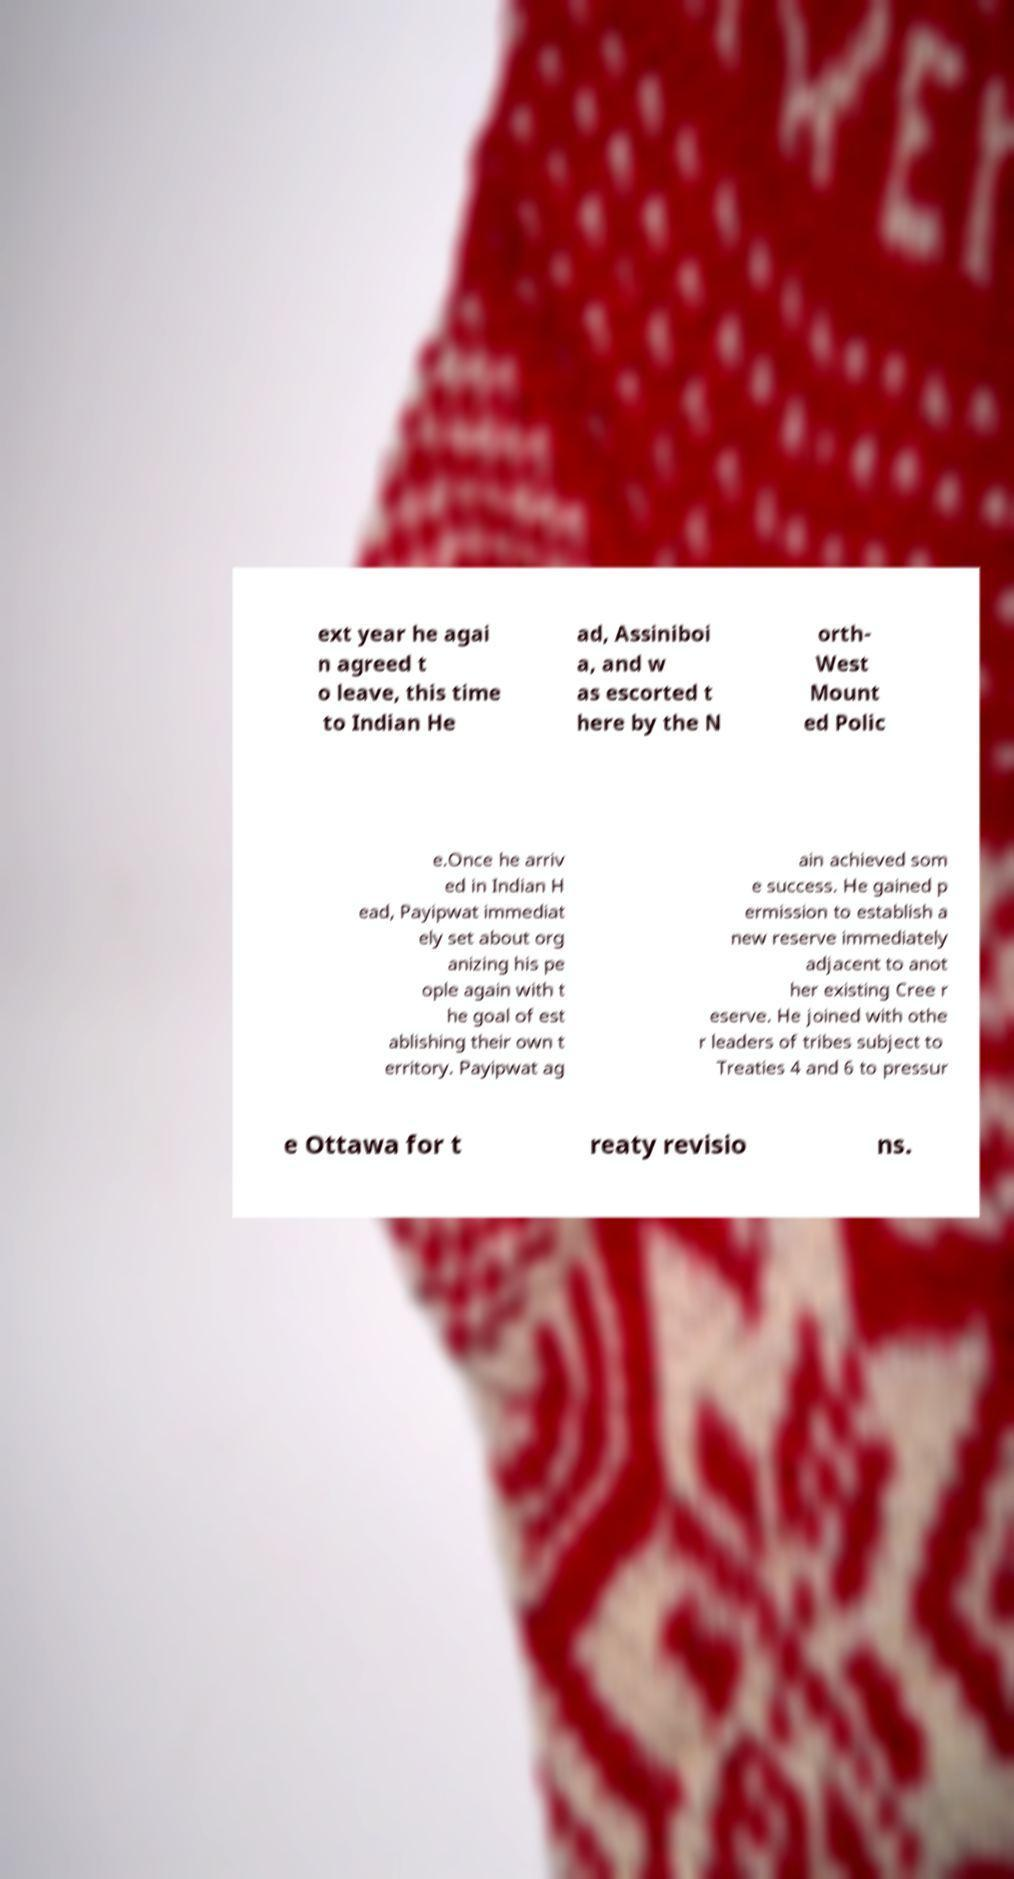Could you extract and type out the text from this image? ext year he agai n agreed t o leave, this time to Indian He ad, Assiniboi a, and w as escorted t here by the N orth- West Mount ed Polic e.Once he arriv ed in Indian H ead, Payipwat immediat ely set about org anizing his pe ople again with t he goal of est ablishing their own t erritory. Payipwat ag ain achieved som e success. He gained p ermission to establish a new reserve immediately adjacent to anot her existing Cree r eserve. He joined with othe r leaders of tribes subject to Treaties 4 and 6 to pressur e Ottawa for t reaty revisio ns. 